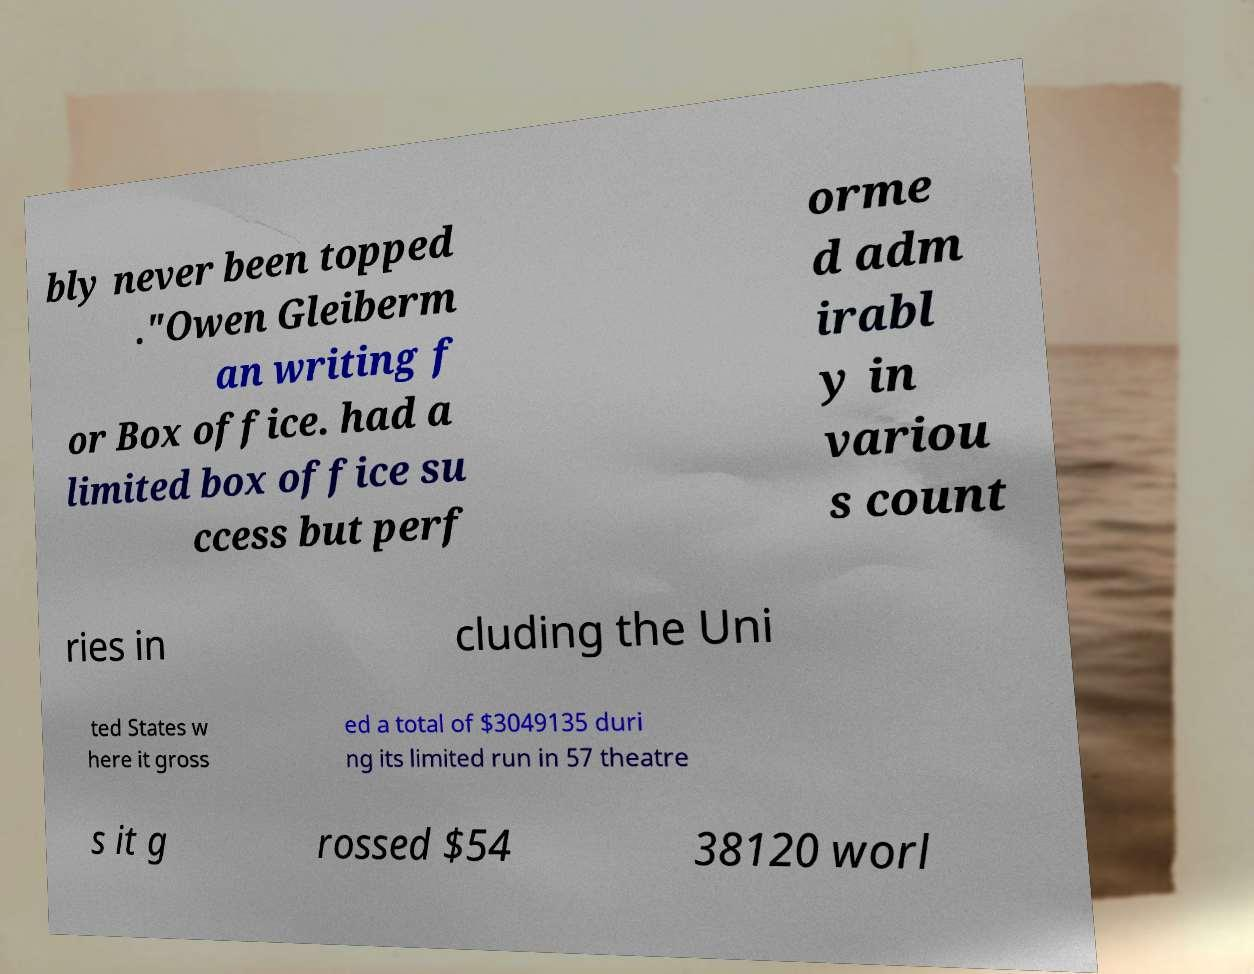Please identify and transcribe the text found in this image. bly never been topped ."Owen Gleiberm an writing f or Box office. had a limited box office su ccess but perf orme d adm irabl y in variou s count ries in cluding the Uni ted States w here it gross ed a total of $3049135 duri ng its limited run in 57 theatre s it g rossed $54 38120 worl 